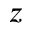<formula> <loc_0><loc_0><loc_500><loc_500>z</formula> 